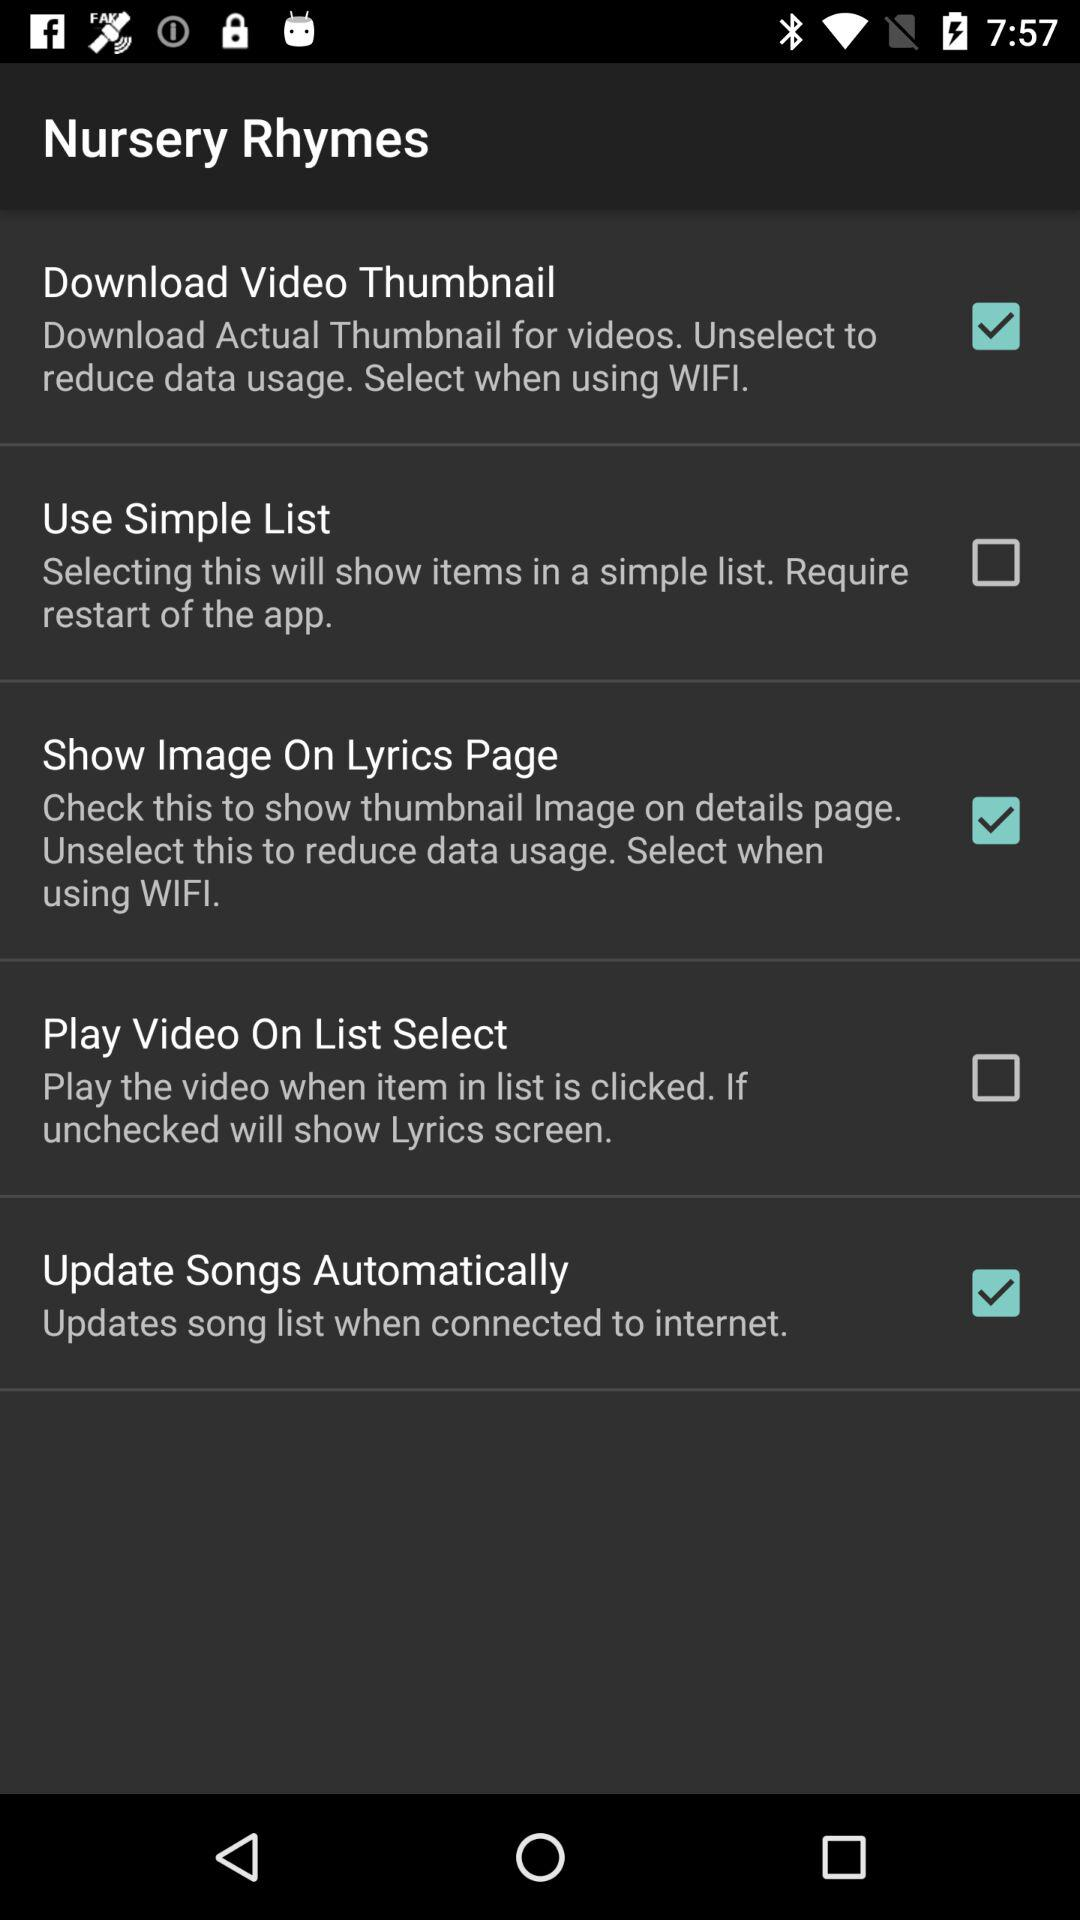What is the status of the "Use Simple List"? The status is off. 